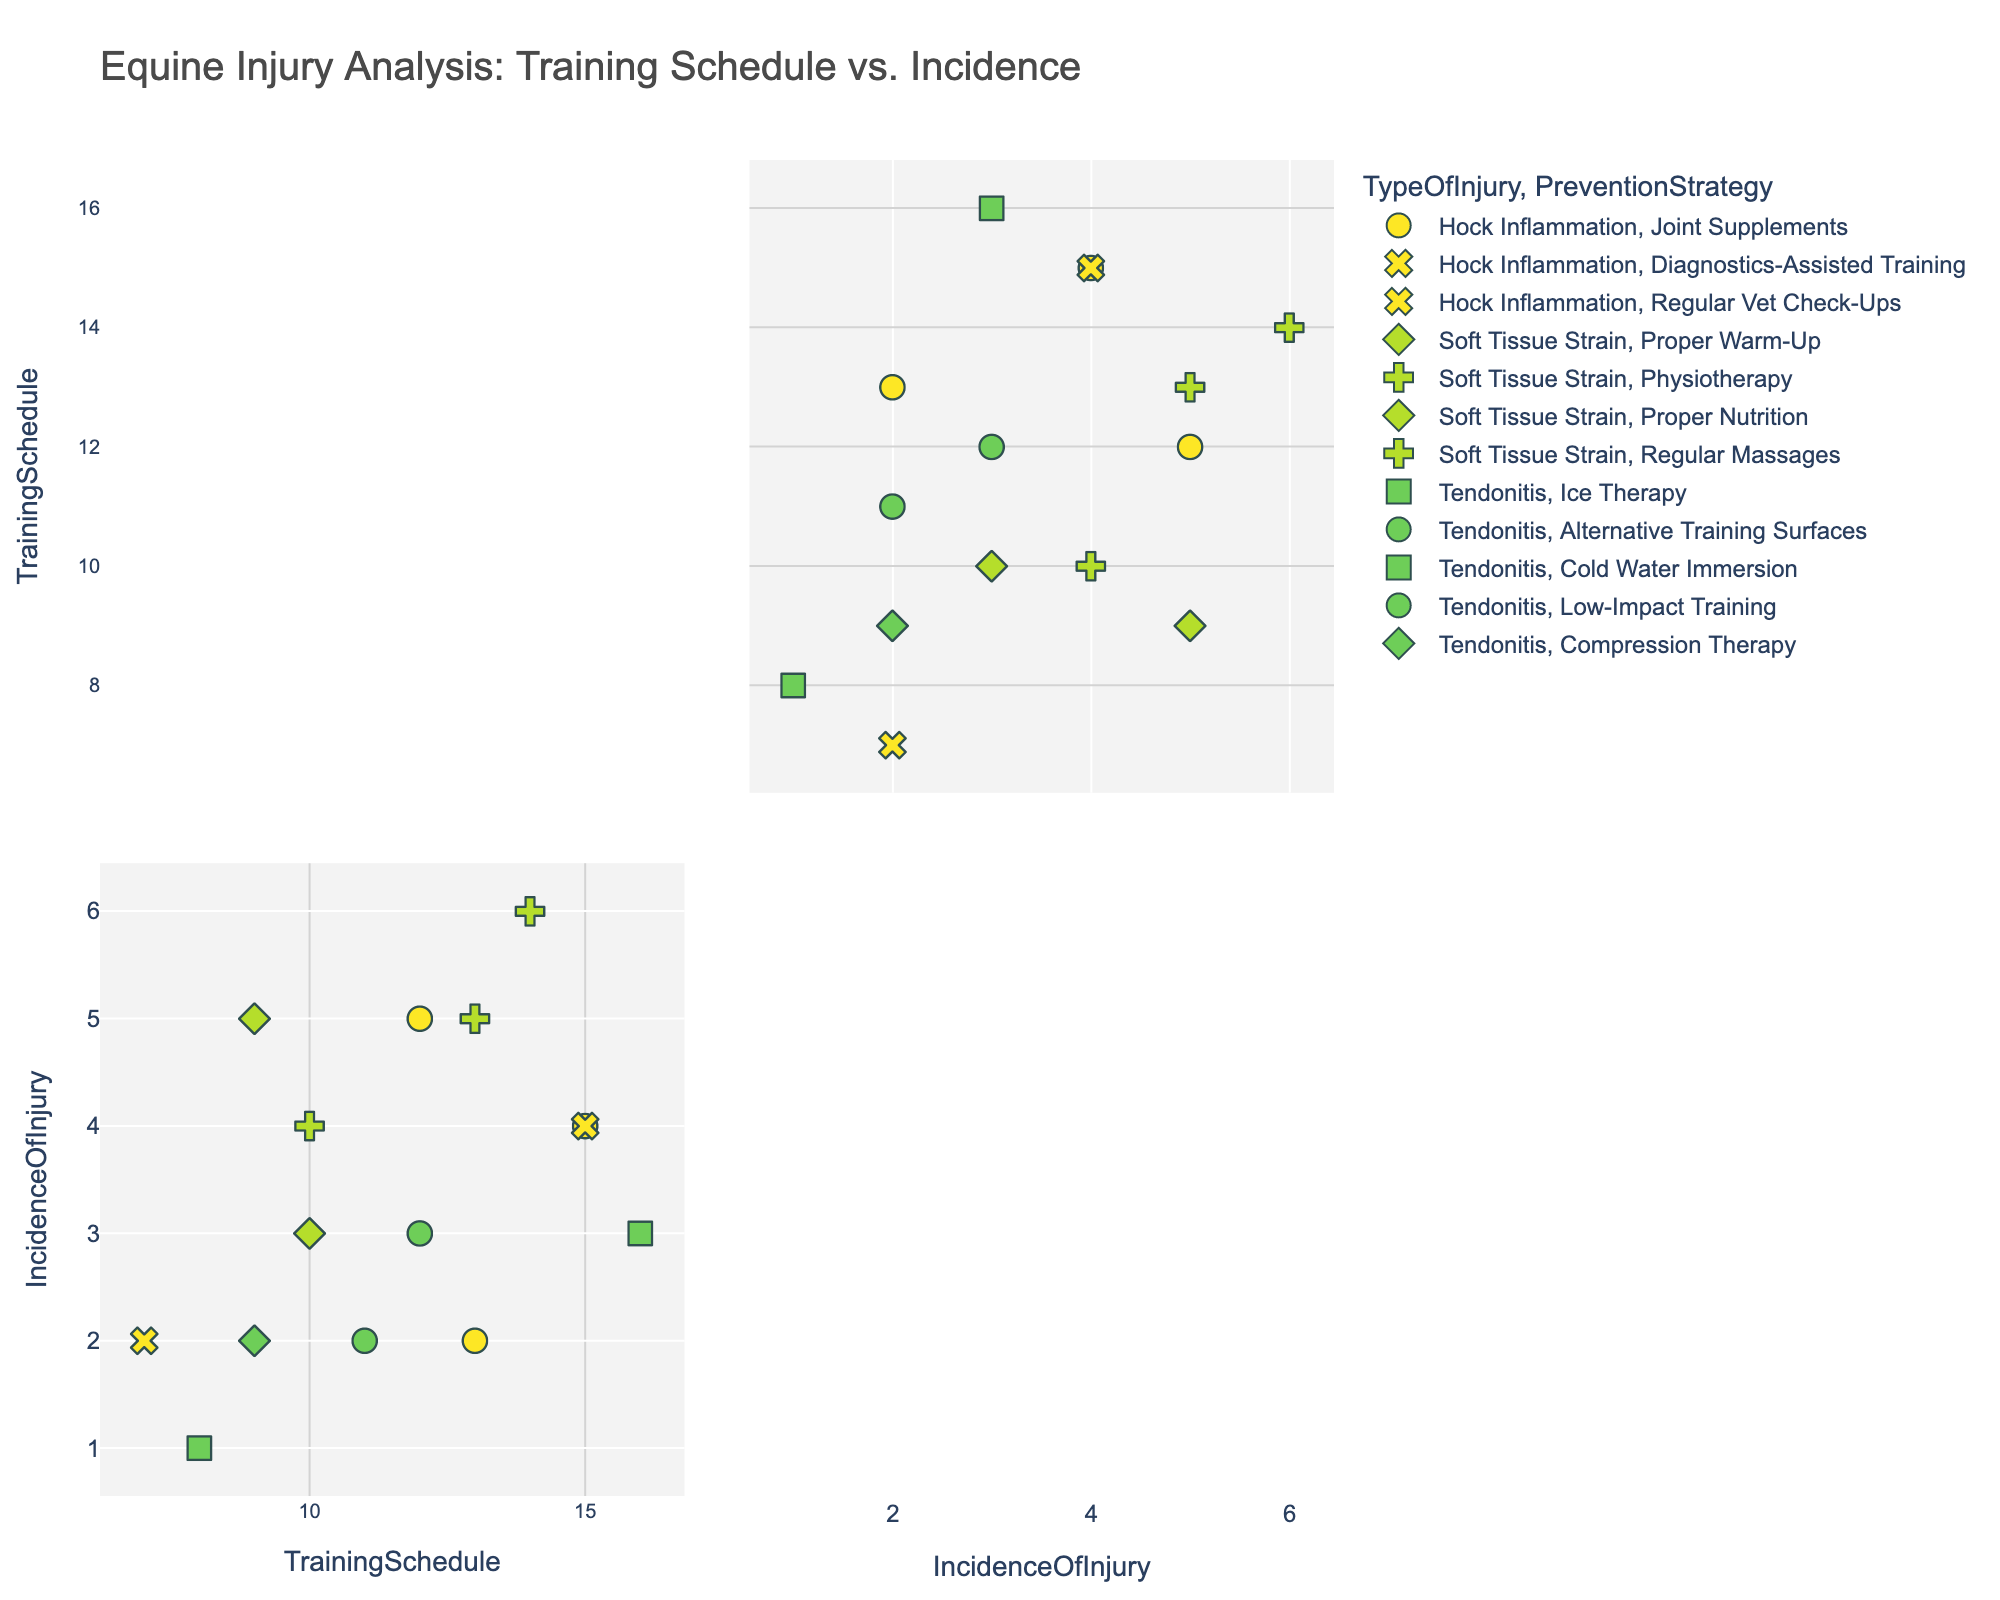What is the title of the figure? The title is usually located at the top of the figure. Here, it states 'Equine Injury Analysis: Training Schedule vs. Incidence'.
Answer: Equine Injury Analysis: Training Schedule vs. Incidence How many data points show a 'Hock Inflammation' injury? Look at the legend for 'TypeOfInjury' and count the data points corresponding to 'Hock Inflammation'.
Answer: 5 What is the range of the 'TrainingSchedule' variable? The 'TrainingSchedule' variable is plotted on both axes, ranging from the minimum to maximum value in that dimension. The minimum training schedule is 7, and the maximum is 16.
Answer: 7 to 16 What is the average incidence of injury for samples using 'Joint Supplements' as a prevention strategy? Identify data points using 'Joint Supplements', and average their 'IncidenceOfInjury' values: (5 + 2 + 4) / 3 = 11 / 3 = 3.67.
Answer: 3.67 Which prevention strategy has the highest incidence of injury for 'Soft Tissue Strain'? Look at 'Soft Tissue Strain' data points and check 'IncidenceOfInjury' values for each 'PreventionStrategy'. 'Physiotherapy' appears to have the highest at 6.
Answer: Physiotherapy Comparing 'Tendonitis' and 'Hock Inflammation', which has a higher average incidence of injury? Calculate the average incidence for both 'Tendonitis' and 'Hock Inflammation'. 'Tendonitis': (1+2+3+2+2) / 5 = 10 / 5 = 2. 'Hock Inflammation': (5+4+2+4) / 4 = 15 / 4 = 3.75.
Answer: Hock Inflammation Are there any data points with both a high training schedule and a low incidence of injury? Look for points on the top right for 'TrainingSchedule' (values around 15 or 16) with low 'IncidenceOfInjury' (values around 1 or 2). Yes, there are such data points.
Answer: Yes What is the most common type of injury observed in the data? Count occurrences of each 'TypeOfInjury' using the color legend; 'Soft Tissue Strain' appears most frequently.
Answer: Soft Tissue Strain Is there a noticeable trend between training schedule and incidence of injury? Visually inspect the scatter plot to ascertain if increasing 'TrainingSchedule' is associated with an increase in 'IncidenceOfInjury', or if there's no clear trend. There doesn’t appear to be a strong trend.
Answer: No clear trend 